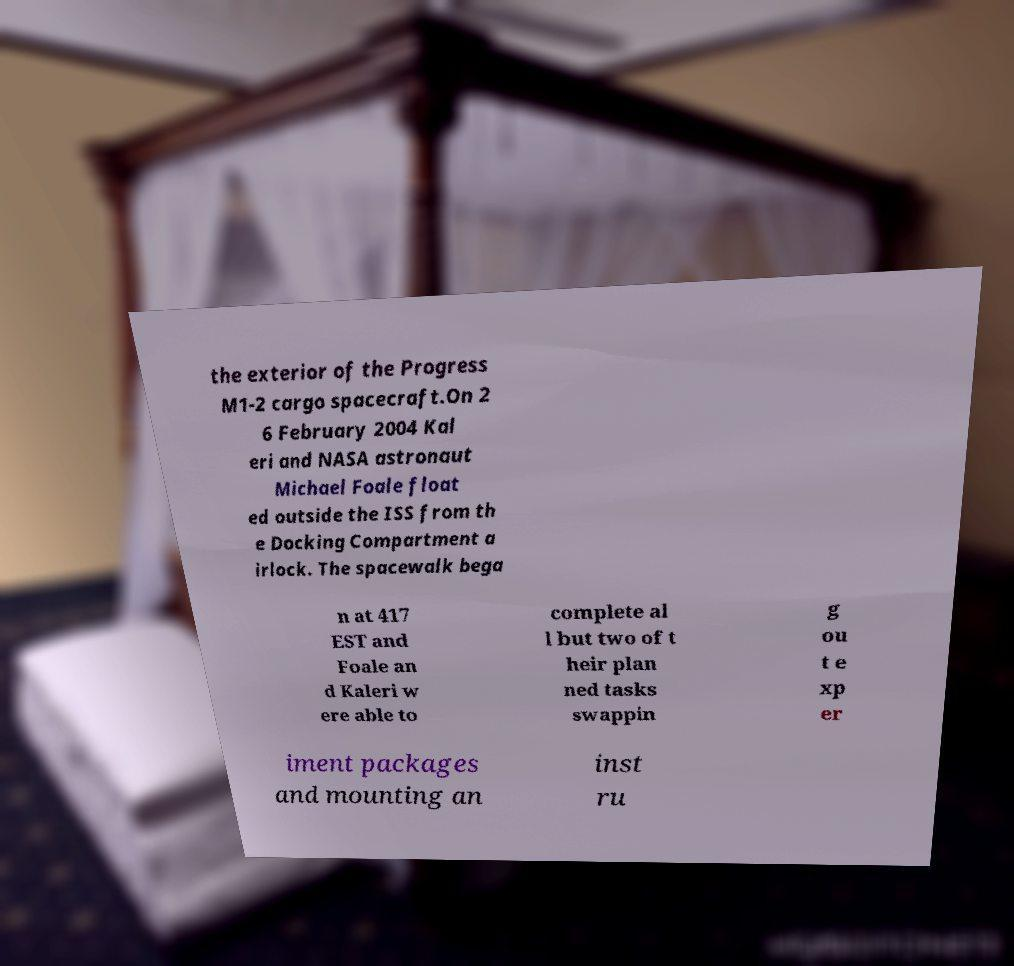Could you assist in decoding the text presented in this image and type it out clearly? the exterior of the Progress M1-2 cargo spacecraft.On 2 6 February 2004 Kal eri and NASA astronaut Michael Foale float ed outside the ISS from th e Docking Compartment a irlock. The spacewalk bega n at 417 EST and Foale an d Kaleri w ere able to complete al l but two of t heir plan ned tasks swappin g ou t e xp er iment packages and mounting an inst ru 